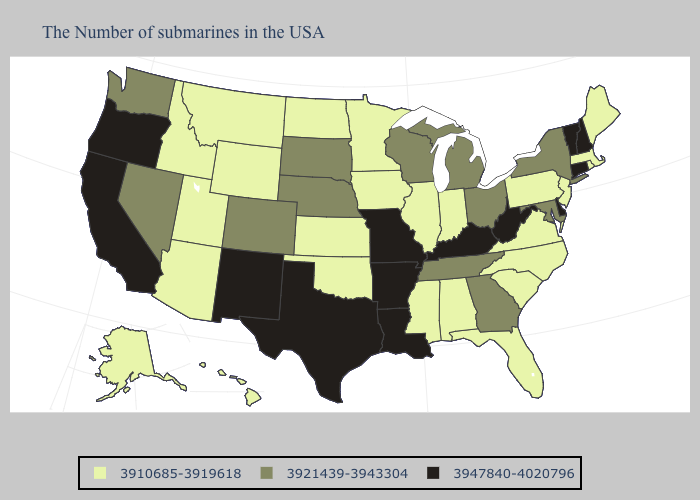Does New Mexico have a lower value than Florida?
Write a very short answer. No. Name the states that have a value in the range 3947840-4020796?
Be succinct. New Hampshire, Vermont, Connecticut, Delaware, West Virginia, Kentucky, Louisiana, Missouri, Arkansas, Texas, New Mexico, California, Oregon. Does the map have missing data?
Answer briefly. No. What is the lowest value in states that border Maine?
Be succinct. 3947840-4020796. Among the states that border Louisiana , does Mississippi have the lowest value?
Be succinct. Yes. Which states have the highest value in the USA?
Give a very brief answer. New Hampshire, Vermont, Connecticut, Delaware, West Virginia, Kentucky, Louisiana, Missouri, Arkansas, Texas, New Mexico, California, Oregon. Name the states that have a value in the range 3921439-3943304?
Short answer required. New York, Maryland, Ohio, Georgia, Michigan, Tennessee, Wisconsin, Nebraska, South Dakota, Colorado, Nevada, Washington. What is the value of South Dakota?
Short answer required. 3921439-3943304. Does New Hampshire have the same value as Texas?
Answer briefly. Yes. What is the value of Colorado?
Answer briefly. 3921439-3943304. Does Illinois have a lower value than Maryland?
Keep it brief. Yes. Among the states that border Nevada , does Oregon have the lowest value?
Short answer required. No. Does Wisconsin have the lowest value in the MidWest?
Quick response, please. No. What is the value of Washington?
Answer briefly. 3921439-3943304. What is the lowest value in the USA?
Concise answer only. 3910685-3919618. 